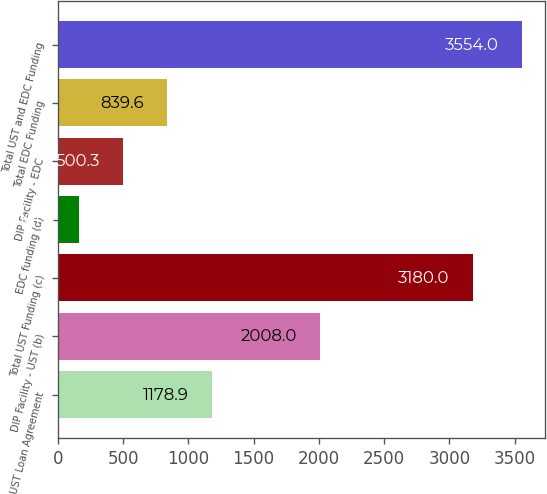Convert chart. <chart><loc_0><loc_0><loc_500><loc_500><bar_chart><fcel>UST Loan Agreement<fcel>DIP Facility - UST (b)<fcel>Total UST Funding (c)<fcel>EDC funding (d)<fcel>DIP Facility - EDC<fcel>Total EDC Funding<fcel>Total UST and EDC Funding<nl><fcel>1178.9<fcel>2008<fcel>3180<fcel>161<fcel>500.3<fcel>839.6<fcel>3554<nl></chart> 